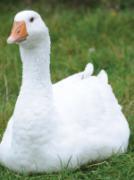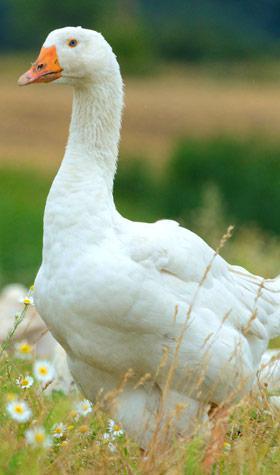The first image is the image on the left, the second image is the image on the right. Examine the images to the left and right. Is the description "There is exactly one animal in the image on the left." accurate? Answer yes or no. Yes. The first image is the image on the left, the second image is the image on the right. Evaluate the accuracy of this statement regarding the images: "No image contains fewer than four white fowl.". Is it true? Answer yes or no. No. 